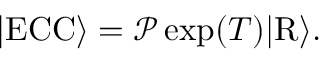<formula> <loc_0><loc_0><loc_500><loc_500>\begin{array} { r } { | E C C \rangle = \mathcal { P } \exp ( T ) | R \rangle . } \end{array}</formula> 